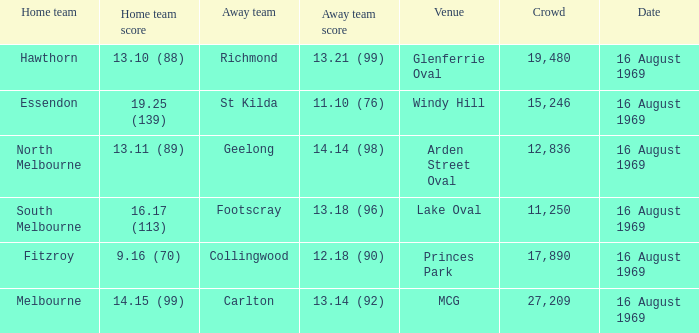What was the away team when the game was at Princes Park? Collingwood. 